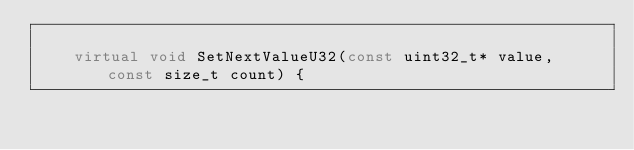<code> <loc_0><loc_0><loc_500><loc_500><_C++_>
		virtual void SetNextValueU32(const uint32_t* value, const size_t count) {</code> 